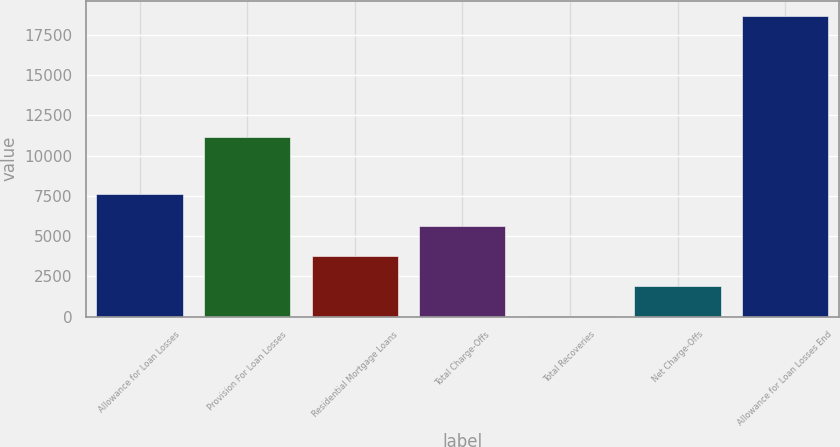Convert chart to OTSL. <chart><loc_0><loc_0><loc_500><loc_500><bar_chart><fcel>Allowance for Loan Losses<fcel>Provision For Loan Losses<fcel>Residential Mortgage Loans<fcel>Total Charge-Offs<fcel>Total Recoveries<fcel>Net Charge-Offs<fcel>Allowance for Loan Losses End<nl><fcel>7593<fcel>11153<fcel>3746<fcel>5614.5<fcel>9<fcel>1877.5<fcel>18694<nl></chart> 